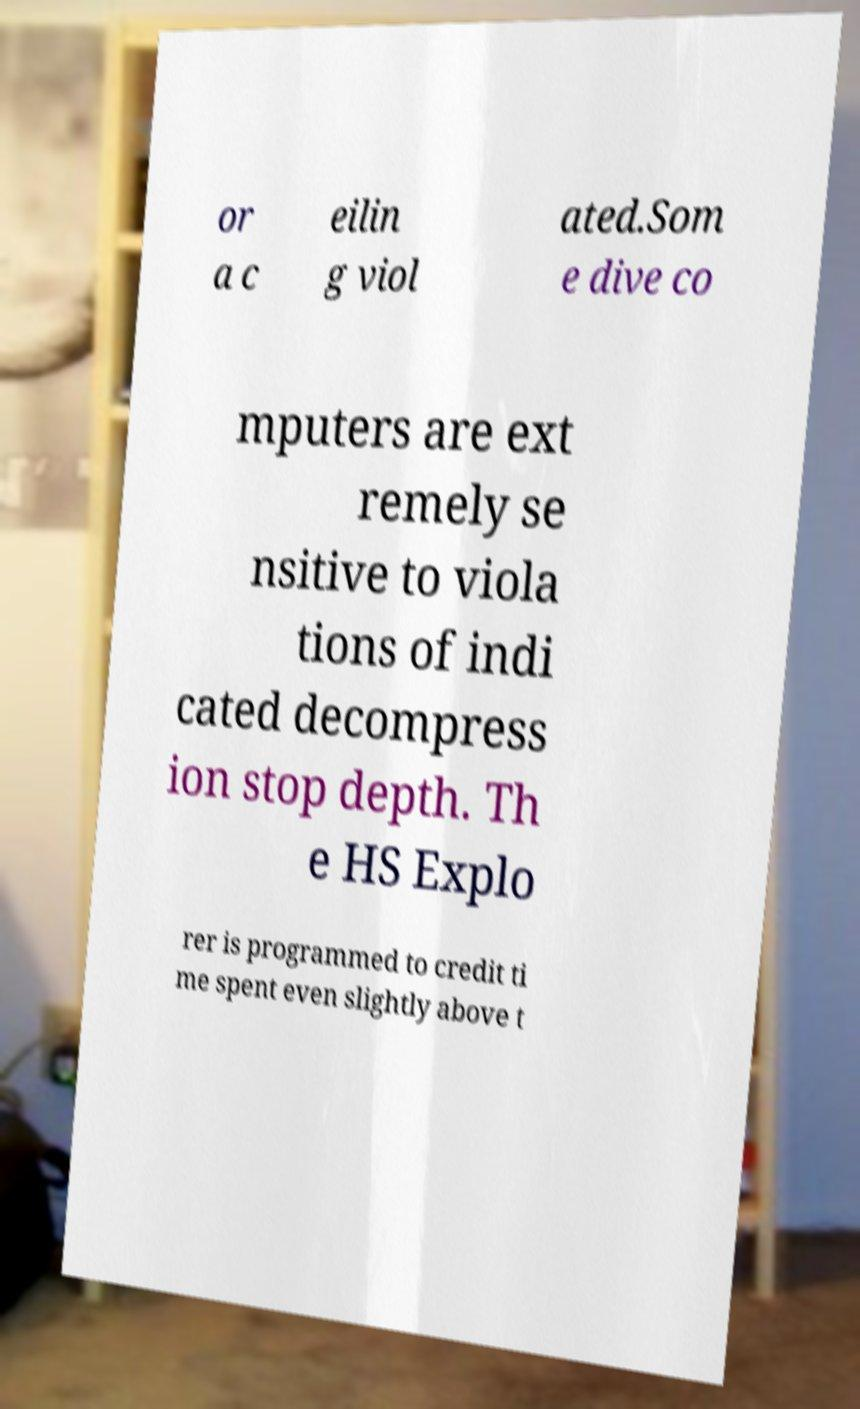What messages or text are displayed in this image? I need them in a readable, typed format. or a c eilin g viol ated.Som e dive co mputers are ext remely se nsitive to viola tions of indi cated decompress ion stop depth. Th e HS Explo rer is programmed to credit ti me spent even slightly above t 